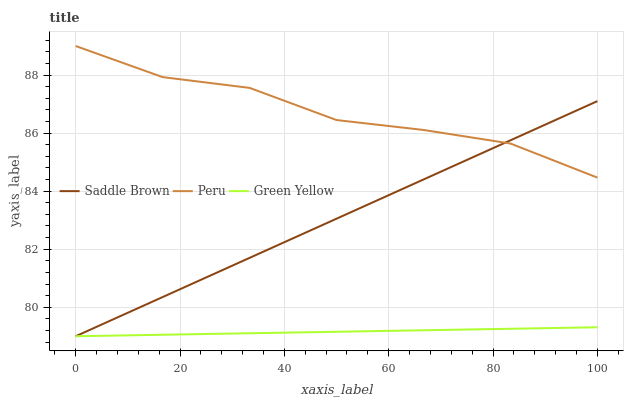Does Saddle Brown have the minimum area under the curve?
Answer yes or no. No. Does Saddle Brown have the maximum area under the curve?
Answer yes or no. No. Is Peru the smoothest?
Answer yes or no. No. Is Saddle Brown the roughest?
Answer yes or no. No. Does Peru have the lowest value?
Answer yes or no. No. Does Saddle Brown have the highest value?
Answer yes or no. No. Is Green Yellow less than Peru?
Answer yes or no. Yes. Is Peru greater than Green Yellow?
Answer yes or no. Yes. Does Green Yellow intersect Peru?
Answer yes or no. No. 